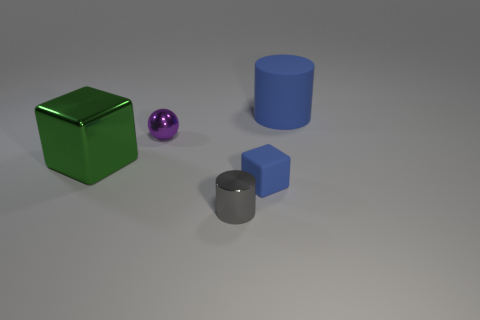Add 1 tiny brown matte spheres. How many objects exist? 6 Subtract all blocks. How many objects are left? 3 Add 1 big things. How many big things are left? 3 Add 4 blue rubber cylinders. How many blue rubber cylinders exist? 5 Subtract 0 green cylinders. How many objects are left? 5 Subtract all big metal blocks. Subtract all large blocks. How many objects are left? 3 